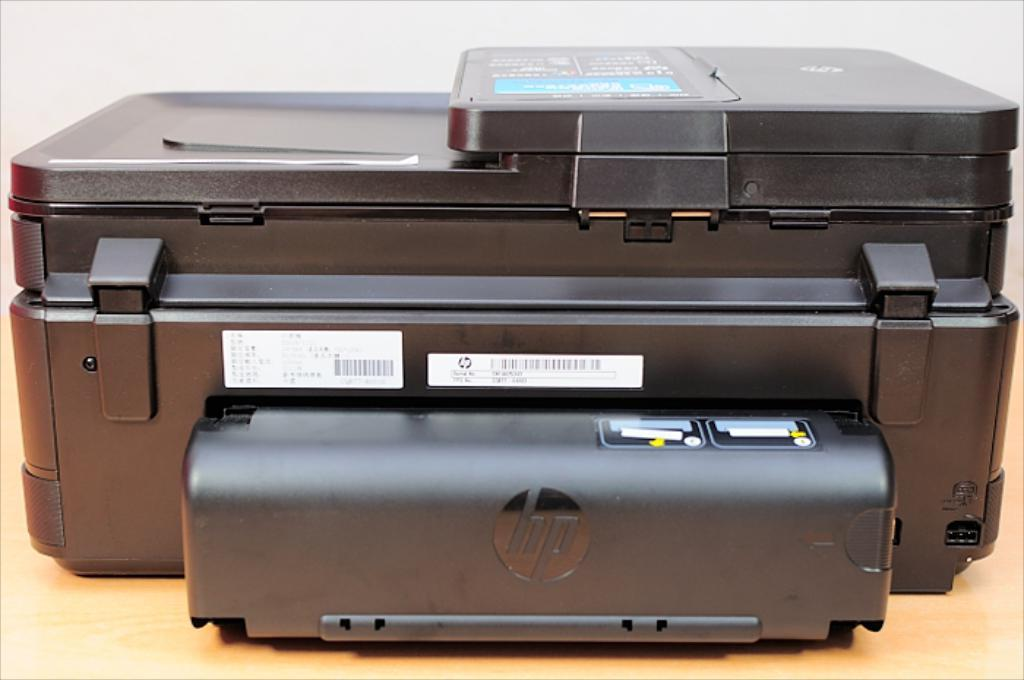What device is present on the wooden surface in the image? There is a scanner on a wooden surface in the image. What type of items are placed near the scanner? There are cards with text in the image. What color is the background of the image? The background of the image is white. How many boys are washing pickles in the image? There are no boys or pickles present in the image. 